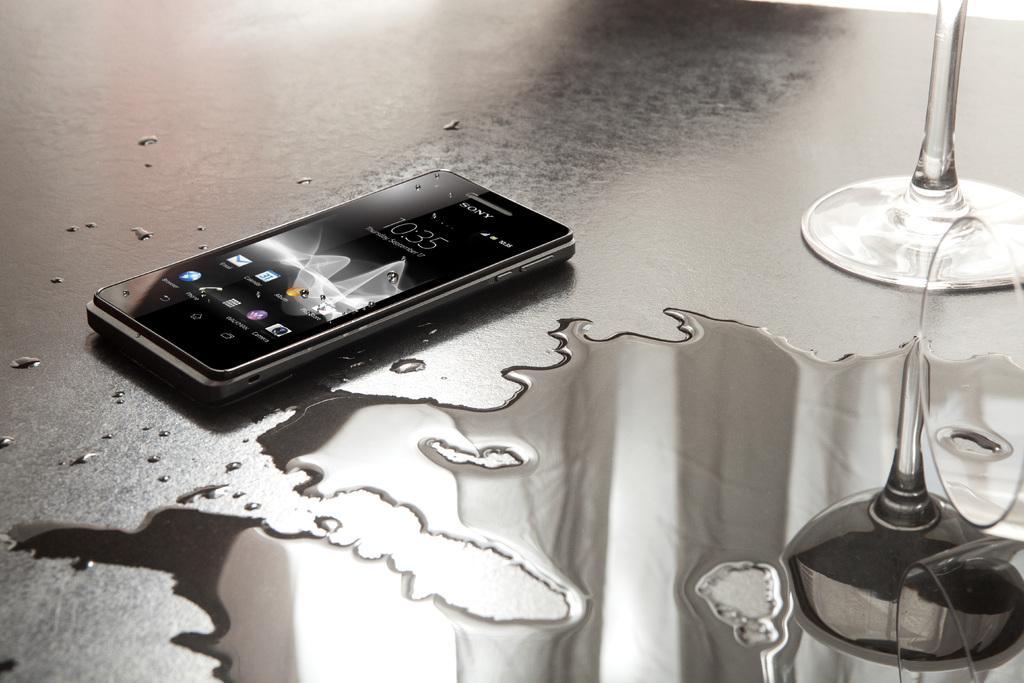Could you give a brief overview of what you see in this image? In this image I can see the mobile, water and the glass object and these are on the black color surface. 